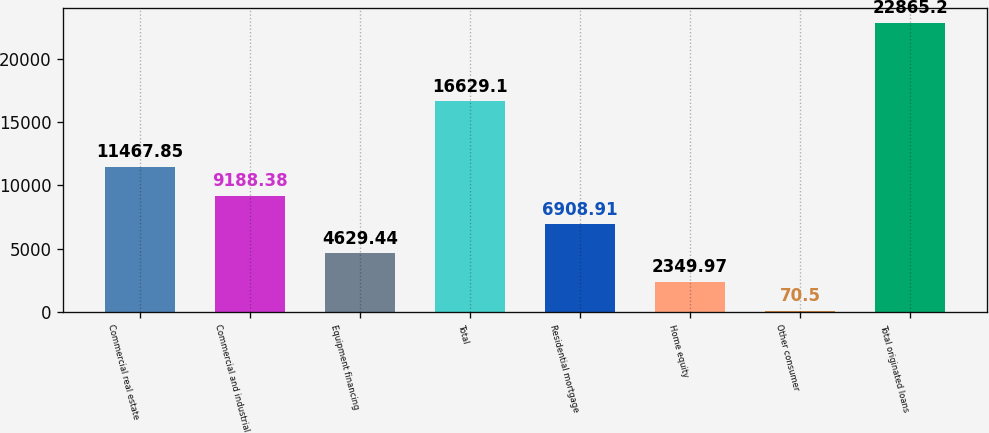<chart> <loc_0><loc_0><loc_500><loc_500><bar_chart><fcel>Commercial real estate<fcel>Commercial and industrial<fcel>Equipment financing<fcel>Total<fcel>Residential mortgage<fcel>Home equity<fcel>Other consumer<fcel>Total originated loans<nl><fcel>11467.9<fcel>9188.38<fcel>4629.44<fcel>16629.1<fcel>6908.91<fcel>2349.97<fcel>70.5<fcel>22865.2<nl></chart> 